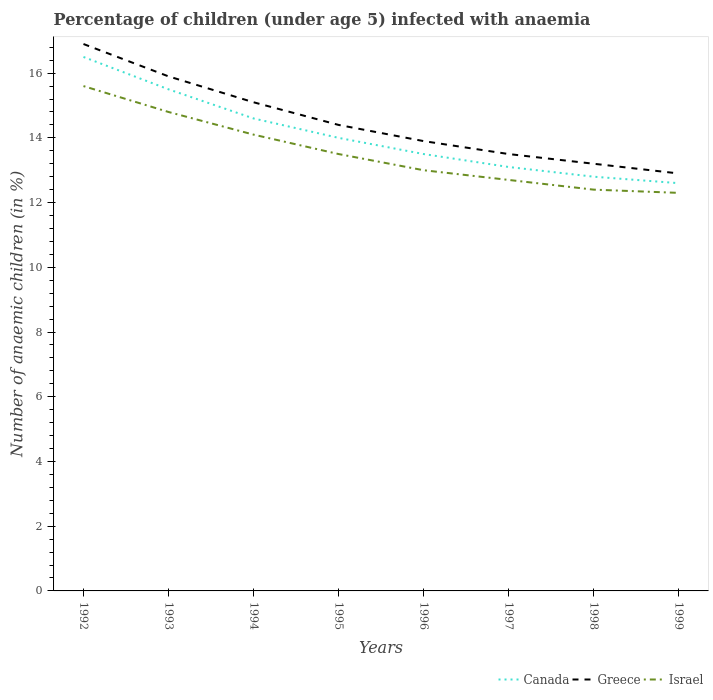How many different coloured lines are there?
Ensure brevity in your answer.  3. Across all years, what is the maximum percentage of children infected with anaemia in in Greece?
Provide a short and direct response. 12.9. In which year was the percentage of children infected with anaemia in in Canada maximum?
Make the answer very short. 1999. What is the total percentage of children infected with anaemia in in Canada in the graph?
Ensure brevity in your answer.  1.9. What is the difference between the highest and the second highest percentage of children infected with anaemia in in Greece?
Your response must be concise. 4. Is the percentage of children infected with anaemia in in Greece strictly greater than the percentage of children infected with anaemia in in Canada over the years?
Provide a short and direct response. No. How many years are there in the graph?
Make the answer very short. 8. Does the graph contain grids?
Your response must be concise. No. How are the legend labels stacked?
Provide a short and direct response. Horizontal. What is the title of the graph?
Your answer should be very brief. Percentage of children (under age 5) infected with anaemia. Does "European Union" appear as one of the legend labels in the graph?
Ensure brevity in your answer.  No. What is the label or title of the X-axis?
Your response must be concise. Years. What is the label or title of the Y-axis?
Your answer should be very brief. Number of anaemic children (in %). What is the Number of anaemic children (in %) in Canada in 1992?
Make the answer very short. 16.5. What is the Number of anaemic children (in %) in Canada in 1993?
Give a very brief answer. 15.5. What is the Number of anaemic children (in %) in Greece in 1993?
Give a very brief answer. 15.9. What is the Number of anaemic children (in %) in Canada in 1994?
Make the answer very short. 14.6. What is the Number of anaemic children (in %) in Israel in 1994?
Keep it short and to the point. 14.1. What is the Number of anaemic children (in %) in Canada in 1995?
Ensure brevity in your answer.  14. What is the Number of anaemic children (in %) in Israel in 1995?
Your answer should be very brief. 13.5. What is the Number of anaemic children (in %) of Canada in 1996?
Offer a terse response. 13.5. What is the Number of anaemic children (in %) in Canada in 1997?
Your answer should be compact. 13.1. What is the Number of anaemic children (in %) in Greece in 1998?
Your answer should be compact. 13.2. What is the Number of anaemic children (in %) of Israel in 1998?
Ensure brevity in your answer.  12.4. What is the Number of anaemic children (in %) of Canada in 1999?
Your answer should be very brief. 12.6. What is the Number of anaemic children (in %) in Israel in 1999?
Provide a succinct answer. 12.3. Across all years, what is the maximum Number of anaemic children (in %) in Israel?
Ensure brevity in your answer.  15.6. What is the total Number of anaemic children (in %) in Canada in the graph?
Provide a succinct answer. 112.6. What is the total Number of anaemic children (in %) of Greece in the graph?
Provide a short and direct response. 115.8. What is the total Number of anaemic children (in %) in Israel in the graph?
Provide a short and direct response. 108.4. What is the difference between the Number of anaemic children (in %) of Canada in 1992 and that in 1993?
Keep it short and to the point. 1. What is the difference between the Number of anaemic children (in %) of Greece in 1992 and that in 1993?
Your answer should be very brief. 1. What is the difference between the Number of anaemic children (in %) of Greece in 1992 and that in 1994?
Make the answer very short. 1.8. What is the difference between the Number of anaemic children (in %) in Israel in 1992 and that in 1994?
Your answer should be compact. 1.5. What is the difference between the Number of anaemic children (in %) in Canada in 1992 and that in 1995?
Ensure brevity in your answer.  2.5. What is the difference between the Number of anaemic children (in %) of Greece in 1992 and that in 1995?
Offer a very short reply. 2.5. What is the difference between the Number of anaemic children (in %) in Canada in 1992 and that in 1996?
Ensure brevity in your answer.  3. What is the difference between the Number of anaemic children (in %) in Israel in 1992 and that in 1996?
Keep it short and to the point. 2.6. What is the difference between the Number of anaemic children (in %) in Canada in 1992 and that in 1997?
Your response must be concise. 3.4. What is the difference between the Number of anaemic children (in %) of Israel in 1992 and that in 1997?
Offer a terse response. 2.9. What is the difference between the Number of anaemic children (in %) in Canada in 1992 and that in 1998?
Give a very brief answer. 3.7. What is the difference between the Number of anaemic children (in %) in Greece in 1992 and that in 1998?
Make the answer very short. 3.7. What is the difference between the Number of anaemic children (in %) in Israel in 1992 and that in 1998?
Your response must be concise. 3.2. What is the difference between the Number of anaemic children (in %) of Israel in 1992 and that in 1999?
Make the answer very short. 3.3. What is the difference between the Number of anaemic children (in %) of Canada in 1993 and that in 1994?
Provide a succinct answer. 0.9. What is the difference between the Number of anaemic children (in %) in Israel in 1993 and that in 1994?
Keep it short and to the point. 0.7. What is the difference between the Number of anaemic children (in %) of Canada in 1993 and that in 1995?
Your answer should be compact. 1.5. What is the difference between the Number of anaemic children (in %) in Canada in 1993 and that in 1996?
Provide a succinct answer. 2. What is the difference between the Number of anaemic children (in %) in Canada in 1993 and that in 1997?
Make the answer very short. 2.4. What is the difference between the Number of anaemic children (in %) in Canada in 1993 and that in 1998?
Provide a succinct answer. 2.7. What is the difference between the Number of anaemic children (in %) in Greece in 1993 and that in 1998?
Ensure brevity in your answer.  2.7. What is the difference between the Number of anaemic children (in %) of Israel in 1993 and that in 1999?
Offer a terse response. 2.5. What is the difference between the Number of anaemic children (in %) of Israel in 1994 and that in 1995?
Ensure brevity in your answer.  0.6. What is the difference between the Number of anaemic children (in %) in Canada in 1994 and that in 1997?
Offer a terse response. 1.5. What is the difference between the Number of anaemic children (in %) in Greece in 1994 and that in 1997?
Give a very brief answer. 1.6. What is the difference between the Number of anaemic children (in %) of Canada in 1994 and that in 1998?
Provide a succinct answer. 1.8. What is the difference between the Number of anaemic children (in %) of Greece in 1995 and that in 1997?
Provide a short and direct response. 0.9. What is the difference between the Number of anaemic children (in %) of Israel in 1995 and that in 1997?
Your answer should be very brief. 0.8. What is the difference between the Number of anaemic children (in %) in Canada in 1995 and that in 1998?
Offer a terse response. 1.2. What is the difference between the Number of anaemic children (in %) of Canada in 1995 and that in 1999?
Make the answer very short. 1.4. What is the difference between the Number of anaemic children (in %) in Israel in 1996 and that in 1997?
Provide a short and direct response. 0.3. What is the difference between the Number of anaemic children (in %) in Canada in 1996 and that in 1998?
Your response must be concise. 0.7. What is the difference between the Number of anaemic children (in %) in Israel in 1996 and that in 1998?
Keep it short and to the point. 0.6. What is the difference between the Number of anaemic children (in %) in Greece in 1996 and that in 1999?
Your response must be concise. 1. What is the difference between the Number of anaemic children (in %) of Israel in 1996 and that in 1999?
Provide a short and direct response. 0.7. What is the difference between the Number of anaemic children (in %) of Canada in 1997 and that in 1999?
Ensure brevity in your answer.  0.5. What is the difference between the Number of anaemic children (in %) in Israel in 1997 and that in 1999?
Give a very brief answer. 0.4. What is the difference between the Number of anaemic children (in %) of Canada in 1998 and that in 1999?
Your response must be concise. 0.2. What is the difference between the Number of anaemic children (in %) in Greece in 1998 and that in 1999?
Ensure brevity in your answer.  0.3. What is the difference between the Number of anaemic children (in %) in Canada in 1992 and the Number of anaemic children (in %) in Israel in 1993?
Offer a terse response. 1.7. What is the difference between the Number of anaemic children (in %) in Canada in 1992 and the Number of anaemic children (in %) in Greece in 1994?
Provide a succinct answer. 1.4. What is the difference between the Number of anaemic children (in %) in Canada in 1992 and the Number of anaemic children (in %) in Israel in 1994?
Offer a terse response. 2.4. What is the difference between the Number of anaemic children (in %) in Canada in 1992 and the Number of anaemic children (in %) in Israel in 1995?
Offer a terse response. 3. What is the difference between the Number of anaemic children (in %) in Canada in 1992 and the Number of anaemic children (in %) in Israel in 1997?
Keep it short and to the point. 3.8. What is the difference between the Number of anaemic children (in %) in Canada in 1992 and the Number of anaemic children (in %) in Israel in 1998?
Offer a very short reply. 4.1. What is the difference between the Number of anaemic children (in %) in Canada in 1992 and the Number of anaemic children (in %) in Greece in 1999?
Your answer should be very brief. 3.6. What is the difference between the Number of anaemic children (in %) of Canada in 1992 and the Number of anaemic children (in %) of Israel in 1999?
Your answer should be compact. 4.2. What is the difference between the Number of anaemic children (in %) of Greece in 1992 and the Number of anaemic children (in %) of Israel in 1999?
Ensure brevity in your answer.  4.6. What is the difference between the Number of anaemic children (in %) in Canada in 1993 and the Number of anaemic children (in %) in Greece in 1994?
Give a very brief answer. 0.4. What is the difference between the Number of anaemic children (in %) of Canada in 1993 and the Number of anaemic children (in %) of Greece in 1995?
Give a very brief answer. 1.1. What is the difference between the Number of anaemic children (in %) in Canada in 1993 and the Number of anaemic children (in %) in Greece in 1996?
Keep it short and to the point. 1.6. What is the difference between the Number of anaemic children (in %) of Greece in 1993 and the Number of anaemic children (in %) of Israel in 1996?
Your response must be concise. 2.9. What is the difference between the Number of anaemic children (in %) of Canada in 1993 and the Number of anaemic children (in %) of Greece in 1997?
Your answer should be compact. 2. What is the difference between the Number of anaemic children (in %) of Canada in 1993 and the Number of anaemic children (in %) of Israel in 1997?
Ensure brevity in your answer.  2.8. What is the difference between the Number of anaemic children (in %) of Greece in 1993 and the Number of anaemic children (in %) of Israel in 1997?
Provide a succinct answer. 3.2. What is the difference between the Number of anaemic children (in %) of Canada in 1993 and the Number of anaemic children (in %) of Israel in 1998?
Provide a short and direct response. 3.1. What is the difference between the Number of anaemic children (in %) of Canada in 1993 and the Number of anaemic children (in %) of Greece in 1999?
Make the answer very short. 2.6. What is the difference between the Number of anaemic children (in %) in Greece in 1993 and the Number of anaemic children (in %) in Israel in 1999?
Ensure brevity in your answer.  3.6. What is the difference between the Number of anaemic children (in %) in Canada in 1994 and the Number of anaemic children (in %) in Greece in 1996?
Make the answer very short. 0.7. What is the difference between the Number of anaemic children (in %) of Canada in 1994 and the Number of anaemic children (in %) of Israel in 1996?
Your answer should be very brief. 1.6. What is the difference between the Number of anaemic children (in %) of Greece in 1994 and the Number of anaemic children (in %) of Israel in 1997?
Make the answer very short. 2.4. What is the difference between the Number of anaemic children (in %) of Canada in 1994 and the Number of anaemic children (in %) of Israel in 1998?
Your answer should be compact. 2.2. What is the difference between the Number of anaemic children (in %) in Canada in 1994 and the Number of anaemic children (in %) in Israel in 1999?
Your answer should be compact. 2.3. What is the difference between the Number of anaemic children (in %) in Greece in 1994 and the Number of anaemic children (in %) in Israel in 1999?
Ensure brevity in your answer.  2.8. What is the difference between the Number of anaemic children (in %) of Greece in 1995 and the Number of anaemic children (in %) of Israel in 1996?
Ensure brevity in your answer.  1.4. What is the difference between the Number of anaemic children (in %) of Canada in 1995 and the Number of anaemic children (in %) of Greece in 1997?
Offer a very short reply. 0.5. What is the difference between the Number of anaemic children (in %) in Canada in 1995 and the Number of anaemic children (in %) in Israel in 1997?
Keep it short and to the point. 1.3. What is the difference between the Number of anaemic children (in %) of Canada in 1995 and the Number of anaemic children (in %) of Greece in 1999?
Keep it short and to the point. 1.1. What is the difference between the Number of anaemic children (in %) in Greece in 1995 and the Number of anaemic children (in %) in Israel in 1999?
Ensure brevity in your answer.  2.1. What is the difference between the Number of anaemic children (in %) in Canada in 1996 and the Number of anaemic children (in %) in Greece in 1998?
Make the answer very short. 0.3. What is the difference between the Number of anaemic children (in %) of Canada in 1996 and the Number of anaemic children (in %) of Israel in 1999?
Make the answer very short. 1.2. What is the difference between the Number of anaemic children (in %) of Greece in 1996 and the Number of anaemic children (in %) of Israel in 1999?
Make the answer very short. 1.6. What is the difference between the Number of anaemic children (in %) of Canada in 1997 and the Number of anaemic children (in %) of Greece in 1999?
Your answer should be very brief. 0.2. What is the difference between the Number of anaemic children (in %) in Canada in 1997 and the Number of anaemic children (in %) in Israel in 1999?
Give a very brief answer. 0.8. What is the difference between the Number of anaemic children (in %) of Canada in 1998 and the Number of anaemic children (in %) of Greece in 1999?
Your answer should be compact. -0.1. What is the average Number of anaemic children (in %) in Canada per year?
Offer a terse response. 14.07. What is the average Number of anaemic children (in %) of Greece per year?
Offer a terse response. 14.47. What is the average Number of anaemic children (in %) in Israel per year?
Your answer should be very brief. 13.55. In the year 1992, what is the difference between the Number of anaemic children (in %) in Canada and Number of anaemic children (in %) in Israel?
Offer a very short reply. 0.9. In the year 1993, what is the difference between the Number of anaemic children (in %) in Canada and Number of anaemic children (in %) in Greece?
Offer a terse response. -0.4. In the year 1994, what is the difference between the Number of anaemic children (in %) of Greece and Number of anaemic children (in %) of Israel?
Provide a short and direct response. 1. In the year 1995, what is the difference between the Number of anaemic children (in %) of Canada and Number of anaemic children (in %) of Greece?
Provide a short and direct response. -0.4. In the year 1995, what is the difference between the Number of anaemic children (in %) in Canada and Number of anaemic children (in %) in Israel?
Offer a terse response. 0.5. In the year 1995, what is the difference between the Number of anaemic children (in %) in Greece and Number of anaemic children (in %) in Israel?
Offer a very short reply. 0.9. In the year 1996, what is the difference between the Number of anaemic children (in %) of Canada and Number of anaemic children (in %) of Greece?
Keep it short and to the point. -0.4. In the year 1996, what is the difference between the Number of anaemic children (in %) in Greece and Number of anaemic children (in %) in Israel?
Offer a very short reply. 0.9. In the year 1997, what is the difference between the Number of anaemic children (in %) in Greece and Number of anaemic children (in %) in Israel?
Your answer should be compact. 0.8. In the year 1998, what is the difference between the Number of anaemic children (in %) in Canada and Number of anaemic children (in %) in Israel?
Ensure brevity in your answer.  0.4. In the year 1998, what is the difference between the Number of anaemic children (in %) in Greece and Number of anaemic children (in %) in Israel?
Ensure brevity in your answer.  0.8. In the year 1999, what is the difference between the Number of anaemic children (in %) of Canada and Number of anaemic children (in %) of Israel?
Provide a short and direct response. 0.3. What is the ratio of the Number of anaemic children (in %) in Canada in 1992 to that in 1993?
Provide a succinct answer. 1.06. What is the ratio of the Number of anaemic children (in %) in Greece in 1992 to that in 1993?
Offer a terse response. 1.06. What is the ratio of the Number of anaemic children (in %) in Israel in 1992 to that in 1993?
Your response must be concise. 1.05. What is the ratio of the Number of anaemic children (in %) of Canada in 1992 to that in 1994?
Offer a very short reply. 1.13. What is the ratio of the Number of anaemic children (in %) of Greece in 1992 to that in 1994?
Offer a very short reply. 1.12. What is the ratio of the Number of anaemic children (in %) of Israel in 1992 to that in 1994?
Provide a succinct answer. 1.11. What is the ratio of the Number of anaemic children (in %) of Canada in 1992 to that in 1995?
Offer a very short reply. 1.18. What is the ratio of the Number of anaemic children (in %) in Greece in 1992 to that in 1995?
Offer a very short reply. 1.17. What is the ratio of the Number of anaemic children (in %) in Israel in 1992 to that in 1995?
Your answer should be compact. 1.16. What is the ratio of the Number of anaemic children (in %) of Canada in 1992 to that in 1996?
Offer a terse response. 1.22. What is the ratio of the Number of anaemic children (in %) in Greece in 1992 to that in 1996?
Make the answer very short. 1.22. What is the ratio of the Number of anaemic children (in %) of Israel in 1992 to that in 1996?
Offer a very short reply. 1.2. What is the ratio of the Number of anaemic children (in %) in Canada in 1992 to that in 1997?
Your response must be concise. 1.26. What is the ratio of the Number of anaemic children (in %) of Greece in 1992 to that in 1997?
Your answer should be very brief. 1.25. What is the ratio of the Number of anaemic children (in %) in Israel in 1992 to that in 1997?
Make the answer very short. 1.23. What is the ratio of the Number of anaemic children (in %) in Canada in 1992 to that in 1998?
Offer a terse response. 1.29. What is the ratio of the Number of anaemic children (in %) of Greece in 1992 to that in 1998?
Give a very brief answer. 1.28. What is the ratio of the Number of anaemic children (in %) in Israel in 1992 to that in 1998?
Your response must be concise. 1.26. What is the ratio of the Number of anaemic children (in %) in Canada in 1992 to that in 1999?
Ensure brevity in your answer.  1.31. What is the ratio of the Number of anaemic children (in %) of Greece in 1992 to that in 1999?
Your answer should be very brief. 1.31. What is the ratio of the Number of anaemic children (in %) in Israel in 1992 to that in 1999?
Your answer should be very brief. 1.27. What is the ratio of the Number of anaemic children (in %) in Canada in 1993 to that in 1994?
Make the answer very short. 1.06. What is the ratio of the Number of anaemic children (in %) of Greece in 1993 to that in 1994?
Provide a short and direct response. 1.05. What is the ratio of the Number of anaemic children (in %) in Israel in 1993 to that in 1994?
Make the answer very short. 1.05. What is the ratio of the Number of anaemic children (in %) of Canada in 1993 to that in 1995?
Your answer should be very brief. 1.11. What is the ratio of the Number of anaemic children (in %) of Greece in 1993 to that in 1995?
Keep it short and to the point. 1.1. What is the ratio of the Number of anaemic children (in %) of Israel in 1993 to that in 1995?
Ensure brevity in your answer.  1.1. What is the ratio of the Number of anaemic children (in %) of Canada in 1993 to that in 1996?
Your response must be concise. 1.15. What is the ratio of the Number of anaemic children (in %) of Greece in 1993 to that in 1996?
Give a very brief answer. 1.14. What is the ratio of the Number of anaemic children (in %) in Israel in 1993 to that in 1996?
Your answer should be compact. 1.14. What is the ratio of the Number of anaemic children (in %) in Canada in 1993 to that in 1997?
Your answer should be very brief. 1.18. What is the ratio of the Number of anaemic children (in %) in Greece in 1993 to that in 1997?
Your answer should be compact. 1.18. What is the ratio of the Number of anaemic children (in %) of Israel in 1993 to that in 1997?
Your answer should be compact. 1.17. What is the ratio of the Number of anaemic children (in %) in Canada in 1993 to that in 1998?
Your answer should be compact. 1.21. What is the ratio of the Number of anaemic children (in %) of Greece in 1993 to that in 1998?
Your answer should be compact. 1.2. What is the ratio of the Number of anaemic children (in %) of Israel in 1993 to that in 1998?
Make the answer very short. 1.19. What is the ratio of the Number of anaemic children (in %) of Canada in 1993 to that in 1999?
Your answer should be very brief. 1.23. What is the ratio of the Number of anaemic children (in %) in Greece in 1993 to that in 1999?
Give a very brief answer. 1.23. What is the ratio of the Number of anaemic children (in %) of Israel in 1993 to that in 1999?
Provide a succinct answer. 1.2. What is the ratio of the Number of anaemic children (in %) of Canada in 1994 to that in 1995?
Your answer should be compact. 1.04. What is the ratio of the Number of anaemic children (in %) in Greece in 1994 to that in 1995?
Offer a very short reply. 1.05. What is the ratio of the Number of anaemic children (in %) in Israel in 1994 to that in 1995?
Provide a short and direct response. 1.04. What is the ratio of the Number of anaemic children (in %) in Canada in 1994 to that in 1996?
Your answer should be very brief. 1.08. What is the ratio of the Number of anaemic children (in %) in Greece in 1994 to that in 1996?
Your answer should be very brief. 1.09. What is the ratio of the Number of anaemic children (in %) in Israel in 1994 to that in 1996?
Offer a terse response. 1.08. What is the ratio of the Number of anaemic children (in %) in Canada in 1994 to that in 1997?
Offer a terse response. 1.11. What is the ratio of the Number of anaemic children (in %) in Greece in 1994 to that in 1997?
Offer a very short reply. 1.12. What is the ratio of the Number of anaemic children (in %) in Israel in 1994 to that in 1997?
Give a very brief answer. 1.11. What is the ratio of the Number of anaemic children (in %) of Canada in 1994 to that in 1998?
Offer a very short reply. 1.14. What is the ratio of the Number of anaemic children (in %) in Greece in 1994 to that in 1998?
Make the answer very short. 1.14. What is the ratio of the Number of anaemic children (in %) in Israel in 1994 to that in 1998?
Make the answer very short. 1.14. What is the ratio of the Number of anaemic children (in %) of Canada in 1994 to that in 1999?
Ensure brevity in your answer.  1.16. What is the ratio of the Number of anaemic children (in %) in Greece in 1994 to that in 1999?
Give a very brief answer. 1.17. What is the ratio of the Number of anaemic children (in %) of Israel in 1994 to that in 1999?
Your answer should be compact. 1.15. What is the ratio of the Number of anaemic children (in %) of Greece in 1995 to that in 1996?
Keep it short and to the point. 1.04. What is the ratio of the Number of anaemic children (in %) in Israel in 1995 to that in 1996?
Offer a terse response. 1.04. What is the ratio of the Number of anaemic children (in %) of Canada in 1995 to that in 1997?
Make the answer very short. 1.07. What is the ratio of the Number of anaemic children (in %) of Greece in 1995 to that in 1997?
Ensure brevity in your answer.  1.07. What is the ratio of the Number of anaemic children (in %) of Israel in 1995 to that in 1997?
Make the answer very short. 1.06. What is the ratio of the Number of anaemic children (in %) in Canada in 1995 to that in 1998?
Provide a short and direct response. 1.09. What is the ratio of the Number of anaemic children (in %) of Greece in 1995 to that in 1998?
Your answer should be very brief. 1.09. What is the ratio of the Number of anaemic children (in %) in Israel in 1995 to that in 1998?
Your answer should be very brief. 1.09. What is the ratio of the Number of anaemic children (in %) of Greece in 1995 to that in 1999?
Provide a short and direct response. 1.12. What is the ratio of the Number of anaemic children (in %) in Israel in 1995 to that in 1999?
Offer a terse response. 1.1. What is the ratio of the Number of anaemic children (in %) in Canada in 1996 to that in 1997?
Provide a short and direct response. 1.03. What is the ratio of the Number of anaemic children (in %) of Greece in 1996 to that in 1997?
Provide a short and direct response. 1.03. What is the ratio of the Number of anaemic children (in %) of Israel in 1996 to that in 1997?
Give a very brief answer. 1.02. What is the ratio of the Number of anaemic children (in %) in Canada in 1996 to that in 1998?
Give a very brief answer. 1.05. What is the ratio of the Number of anaemic children (in %) of Greece in 1996 to that in 1998?
Offer a very short reply. 1.05. What is the ratio of the Number of anaemic children (in %) in Israel in 1996 to that in 1998?
Keep it short and to the point. 1.05. What is the ratio of the Number of anaemic children (in %) of Canada in 1996 to that in 1999?
Ensure brevity in your answer.  1.07. What is the ratio of the Number of anaemic children (in %) in Greece in 1996 to that in 1999?
Your answer should be compact. 1.08. What is the ratio of the Number of anaemic children (in %) of Israel in 1996 to that in 1999?
Your answer should be very brief. 1.06. What is the ratio of the Number of anaemic children (in %) of Canada in 1997 to that in 1998?
Provide a succinct answer. 1.02. What is the ratio of the Number of anaemic children (in %) of Greece in 1997 to that in 1998?
Keep it short and to the point. 1.02. What is the ratio of the Number of anaemic children (in %) in Israel in 1997 to that in 1998?
Provide a short and direct response. 1.02. What is the ratio of the Number of anaemic children (in %) of Canada in 1997 to that in 1999?
Make the answer very short. 1.04. What is the ratio of the Number of anaemic children (in %) in Greece in 1997 to that in 1999?
Your answer should be compact. 1.05. What is the ratio of the Number of anaemic children (in %) in Israel in 1997 to that in 1999?
Your answer should be very brief. 1.03. What is the ratio of the Number of anaemic children (in %) in Canada in 1998 to that in 1999?
Provide a succinct answer. 1.02. What is the ratio of the Number of anaemic children (in %) of Greece in 1998 to that in 1999?
Offer a very short reply. 1.02. What is the difference between the highest and the second highest Number of anaemic children (in %) of Canada?
Offer a terse response. 1. What is the difference between the highest and the second highest Number of anaemic children (in %) of Greece?
Your answer should be very brief. 1. What is the difference between the highest and the lowest Number of anaemic children (in %) of Canada?
Your answer should be very brief. 3.9. What is the difference between the highest and the lowest Number of anaemic children (in %) in Greece?
Your answer should be very brief. 4. 